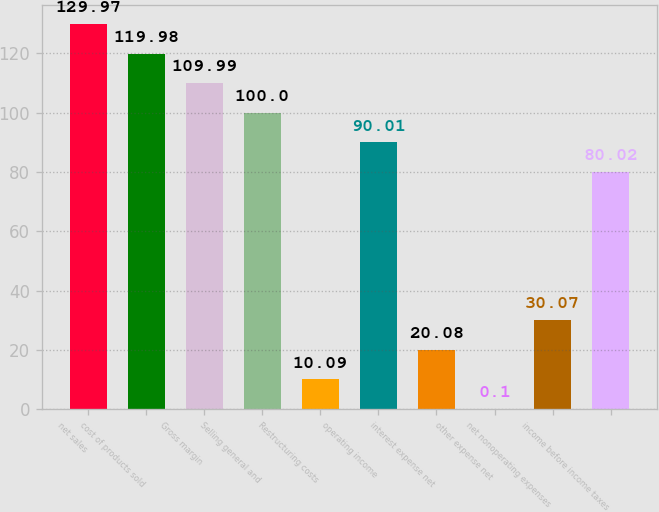<chart> <loc_0><loc_0><loc_500><loc_500><bar_chart><fcel>net sales<fcel>cost of products sold<fcel>Gross margin<fcel>Selling general and<fcel>Restructuring costs<fcel>operating income<fcel>interest expense net<fcel>other expense net<fcel>net nonoperating expenses<fcel>income before income taxes<nl><fcel>129.97<fcel>119.98<fcel>109.99<fcel>100<fcel>10.09<fcel>90.01<fcel>20.08<fcel>0.1<fcel>30.07<fcel>80.02<nl></chart> 